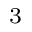<formula> <loc_0><loc_0><loc_500><loc_500>_ { 3 }</formula> 